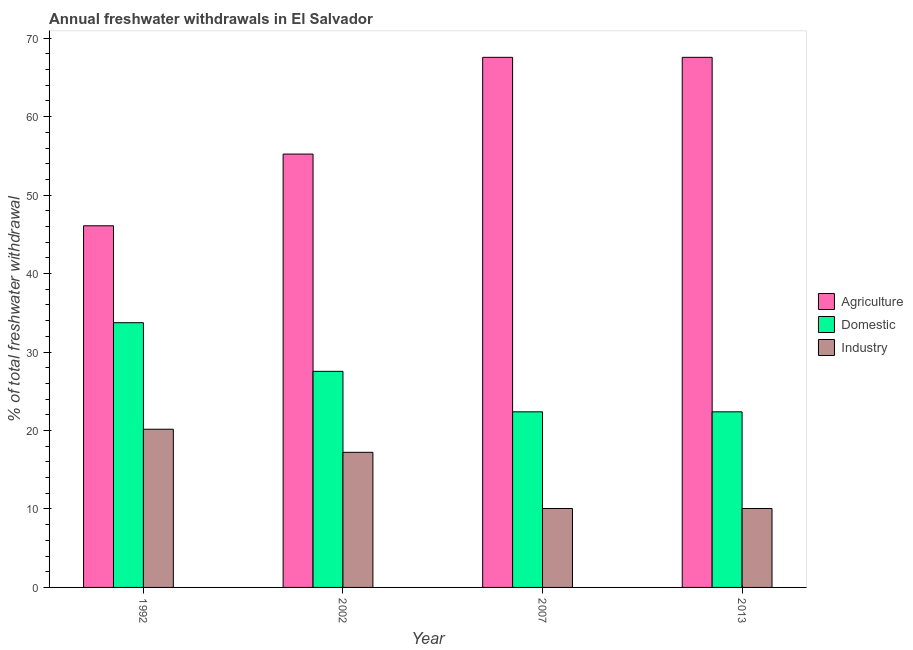How many different coloured bars are there?
Your answer should be very brief. 3. Are the number of bars per tick equal to the number of legend labels?
Your answer should be very brief. Yes. Are the number of bars on each tick of the X-axis equal?
Keep it short and to the point. Yes. How many bars are there on the 1st tick from the left?
Your response must be concise. 3. In how many cases, is the number of bars for a given year not equal to the number of legend labels?
Provide a succinct answer. 0. What is the percentage of freshwater withdrawal for agriculture in 2007?
Offer a terse response. 67.56. Across all years, what is the maximum percentage of freshwater withdrawal for industry?
Your answer should be very brief. 20.16. Across all years, what is the minimum percentage of freshwater withdrawal for agriculture?
Offer a very short reply. 46.09. What is the total percentage of freshwater withdrawal for industry in the graph?
Give a very brief answer. 57.5. What is the difference between the percentage of freshwater withdrawal for domestic purposes in 1992 and that in 2002?
Provide a short and direct response. 6.2. What is the difference between the percentage of freshwater withdrawal for agriculture in 2007 and the percentage of freshwater withdrawal for domestic purposes in 2002?
Keep it short and to the point. 12.33. What is the average percentage of freshwater withdrawal for agriculture per year?
Give a very brief answer. 59.11. In the year 2007, what is the difference between the percentage of freshwater withdrawal for domestic purposes and percentage of freshwater withdrawal for agriculture?
Your answer should be very brief. 0. In how many years, is the percentage of freshwater withdrawal for agriculture greater than 58 %?
Make the answer very short. 2. What is the ratio of the percentage of freshwater withdrawal for domestic purposes in 1992 to that in 2002?
Your answer should be very brief. 1.23. What is the difference between the highest and the second highest percentage of freshwater withdrawal for agriculture?
Your answer should be compact. 0. What is the difference between the highest and the lowest percentage of freshwater withdrawal for domestic purposes?
Your answer should be very brief. 11.36. Is the sum of the percentage of freshwater withdrawal for domestic purposes in 2007 and 2013 greater than the maximum percentage of freshwater withdrawal for industry across all years?
Make the answer very short. Yes. What does the 3rd bar from the left in 2007 represents?
Offer a very short reply. Industry. What does the 2nd bar from the right in 2002 represents?
Ensure brevity in your answer.  Domestic. Is it the case that in every year, the sum of the percentage of freshwater withdrawal for agriculture and percentage of freshwater withdrawal for domestic purposes is greater than the percentage of freshwater withdrawal for industry?
Provide a succinct answer. Yes. Are all the bars in the graph horizontal?
Provide a short and direct response. No. How many years are there in the graph?
Your answer should be very brief. 4. Are the values on the major ticks of Y-axis written in scientific E-notation?
Ensure brevity in your answer.  No. Where does the legend appear in the graph?
Your answer should be very brief. Center right. How are the legend labels stacked?
Your answer should be compact. Vertical. What is the title of the graph?
Provide a succinct answer. Annual freshwater withdrawals in El Salvador. Does "Social Protection" appear as one of the legend labels in the graph?
Ensure brevity in your answer.  No. What is the label or title of the Y-axis?
Your answer should be very brief. % of total freshwater withdrawal. What is the % of total freshwater withdrawal in Agriculture in 1992?
Give a very brief answer. 46.09. What is the % of total freshwater withdrawal of Domestic in 1992?
Provide a short and direct response. 33.74. What is the % of total freshwater withdrawal in Industry in 1992?
Ensure brevity in your answer.  20.16. What is the % of total freshwater withdrawal of Agriculture in 2002?
Your answer should be compact. 55.23. What is the % of total freshwater withdrawal of Domestic in 2002?
Keep it short and to the point. 27.54. What is the % of total freshwater withdrawal of Industry in 2002?
Keep it short and to the point. 17.22. What is the % of total freshwater withdrawal of Agriculture in 2007?
Offer a very short reply. 67.56. What is the % of total freshwater withdrawal of Domestic in 2007?
Offer a terse response. 22.38. What is the % of total freshwater withdrawal in Industry in 2007?
Provide a short and direct response. 10.06. What is the % of total freshwater withdrawal of Agriculture in 2013?
Ensure brevity in your answer.  67.56. What is the % of total freshwater withdrawal of Domestic in 2013?
Your response must be concise. 22.38. What is the % of total freshwater withdrawal in Industry in 2013?
Your answer should be very brief. 10.06. Across all years, what is the maximum % of total freshwater withdrawal in Agriculture?
Provide a succinct answer. 67.56. Across all years, what is the maximum % of total freshwater withdrawal of Domestic?
Give a very brief answer. 33.74. Across all years, what is the maximum % of total freshwater withdrawal in Industry?
Your response must be concise. 20.16. Across all years, what is the minimum % of total freshwater withdrawal in Agriculture?
Make the answer very short. 46.09. Across all years, what is the minimum % of total freshwater withdrawal of Domestic?
Keep it short and to the point. 22.38. Across all years, what is the minimum % of total freshwater withdrawal in Industry?
Provide a succinct answer. 10.06. What is the total % of total freshwater withdrawal of Agriculture in the graph?
Give a very brief answer. 236.44. What is the total % of total freshwater withdrawal of Domestic in the graph?
Your response must be concise. 106.04. What is the total % of total freshwater withdrawal of Industry in the graph?
Offer a very short reply. 57.5. What is the difference between the % of total freshwater withdrawal in Agriculture in 1992 and that in 2002?
Provide a short and direct response. -9.14. What is the difference between the % of total freshwater withdrawal in Domestic in 1992 and that in 2002?
Your response must be concise. 6.2. What is the difference between the % of total freshwater withdrawal of Industry in 1992 and that in 2002?
Your response must be concise. 2.94. What is the difference between the % of total freshwater withdrawal of Agriculture in 1992 and that in 2007?
Your answer should be very brief. -21.47. What is the difference between the % of total freshwater withdrawal in Domestic in 1992 and that in 2007?
Ensure brevity in your answer.  11.36. What is the difference between the % of total freshwater withdrawal of Agriculture in 1992 and that in 2013?
Your answer should be compact. -21.47. What is the difference between the % of total freshwater withdrawal of Domestic in 1992 and that in 2013?
Your answer should be compact. 11.36. What is the difference between the % of total freshwater withdrawal in Industry in 1992 and that in 2013?
Give a very brief answer. 10.1. What is the difference between the % of total freshwater withdrawal of Agriculture in 2002 and that in 2007?
Your response must be concise. -12.33. What is the difference between the % of total freshwater withdrawal of Domestic in 2002 and that in 2007?
Provide a short and direct response. 5.16. What is the difference between the % of total freshwater withdrawal of Industry in 2002 and that in 2007?
Offer a very short reply. 7.16. What is the difference between the % of total freshwater withdrawal of Agriculture in 2002 and that in 2013?
Your answer should be very brief. -12.33. What is the difference between the % of total freshwater withdrawal in Domestic in 2002 and that in 2013?
Your answer should be very brief. 5.16. What is the difference between the % of total freshwater withdrawal in Industry in 2002 and that in 2013?
Provide a short and direct response. 7.16. What is the difference between the % of total freshwater withdrawal of Agriculture in 2007 and that in 2013?
Provide a succinct answer. 0. What is the difference between the % of total freshwater withdrawal in Domestic in 2007 and that in 2013?
Give a very brief answer. 0. What is the difference between the % of total freshwater withdrawal of Agriculture in 1992 and the % of total freshwater withdrawal of Domestic in 2002?
Give a very brief answer. 18.55. What is the difference between the % of total freshwater withdrawal of Agriculture in 1992 and the % of total freshwater withdrawal of Industry in 2002?
Your answer should be very brief. 28.87. What is the difference between the % of total freshwater withdrawal in Domestic in 1992 and the % of total freshwater withdrawal in Industry in 2002?
Keep it short and to the point. 16.52. What is the difference between the % of total freshwater withdrawal in Agriculture in 1992 and the % of total freshwater withdrawal in Domestic in 2007?
Your response must be concise. 23.71. What is the difference between the % of total freshwater withdrawal in Agriculture in 1992 and the % of total freshwater withdrawal in Industry in 2007?
Provide a succinct answer. 36.03. What is the difference between the % of total freshwater withdrawal in Domestic in 1992 and the % of total freshwater withdrawal in Industry in 2007?
Your answer should be very brief. 23.68. What is the difference between the % of total freshwater withdrawal of Agriculture in 1992 and the % of total freshwater withdrawal of Domestic in 2013?
Your answer should be very brief. 23.71. What is the difference between the % of total freshwater withdrawal of Agriculture in 1992 and the % of total freshwater withdrawal of Industry in 2013?
Keep it short and to the point. 36.03. What is the difference between the % of total freshwater withdrawal of Domestic in 1992 and the % of total freshwater withdrawal of Industry in 2013?
Your answer should be compact. 23.68. What is the difference between the % of total freshwater withdrawal of Agriculture in 2002 and the % of total freshwater withdrawal of Domestic in 2007?
Make the answer very short. 32.85. What is the difference between the % of total freshwater withdrawal in Agriculture in 2002 and the % of total freshwater withdrawal in Industry in 2007?
Keep it short and to the point. 45.17. What is the difference between the % of total freshwater withdrawal in Domestic in 2002 and the % of total freshwater withdrawal in Industry in 2007?
Your answer should be very brief. 17.48. What is the difference between the % of total freshwater withdrawal in Agriculture in 2002 and the % of total freshwater withdrawal in Domestic in 2013?
Ensure brevity in your answer.  32.85. What is the difference between the % of total freshwater withdrawal in Agriculture in 2002 and the % of total freshwater withdrawal in Industry in 2013?
Provide a succinct answer. 45.17. What is the difference between the % of total freshwater withdrawal of Domestic in 2002 and the % of total freshwater withdrawal of Industry in 2013?
Keep it short and to the point. 17.48. What is the difference between the % of total freshwater withdrawal of Agriculture in 2007 and the % of total freshwater withdrawal of Domestic in 2013?
Your answer should be very brief. 45.18. What is the difference between the % of total freshwater withdrawal of Agriculture in 2007 and the % of total freshwater withdrawal of Industry in 2013?
Give a very brief answer. 57.5. What is the difference between the % of total freshwater withdrawal of Domestic in 2007 and the % of total freshwater withdrawal of Industry in 2013?
Provide a succinct answer. 12.32. What is the average % of total freshwater withdrawal of Agriculture per year?
Your answer should be compact. 59.11. What is the average % of total freshwater withdrawal of Domestic per year?
Make the answer very short. 26.51. What is the average % of total freshwater withdrawal in Industry per year?
Offer a very short reply. 14.38. In the year 1992, what is the difference between the % of total freshwater withdrawal of Agriculture and % of total freshwater withdrawal of Domestic?
Provide a succinct answer. 12.35. In the year 1992, what is the difference between the % of total freshwater withdrawal of Agriculture and % of total freshwater withdrawal of Industry?
Ensure brevity in your answer.  25.93. In the year 1992, what is the difference between the % of total freshwater withdrawal of Domestic and % of total freshwater withdrawal of Industry?
Your answer should be very brief. 13.58. In the year 2002, what is the difference between the % of total freshwater withdrawal of Agriculture and % of total freshwater withdrawal of Domestic?
Provide a succinct answer. 27.69. In the year 2002, what is the difference between the % of total freshwater withdrawal in Agriculture and % of total freshwater withdrawal in Industry?
Provide a succinct answer. 38.01. In the year 2002, what is the difference between the % of total freshwater withdrawal of Domestic and % of total freshwater withdrawal of Industry?
Provide a short and direct response. 10.32. In the year 2007, what is the difference between the % of total freshwater withdrawal of Agriculture and % of total freshwater withdrawal of Domestic?
Provide a short and direct response. 45.18. In the year 2007, what is the difference between the % of total freshwater withdrawal in Agriculture and % of total freshwater withdrawal in Industry?
Ensure brevity in your answer.  57.5. In the year 2007, what is the difference between the % of total freshwater withdrawal of Domestic and % of total freshwater withdrawal of Industry?
Offer a very short reply. 12.32. In the year 2013, what is the difference between the % of total freshwater withdrawal in Agriculture and % of total freshwater withdrawal in Domestic?
Provide a succinct answer. 45.18. In the year 2013, what is the difference between the % of total freshwater withdrawal in Agriculture and % of total freshwater withdrawal in Industry?
Your answer should be compact. 57.5. In the year 2013, what is the difference between the % of total freshwater withdrawal of Domestic and % of total freshwater withdrawal of Industry?
Your answer should be very brief. 12.32. What is the ratio of the % of total freshwater withdrawal of Agriculture in 1992 to that in 2002?
Give a very brief answer. 0.83. What is the ratio of the % of total freshwater withdrawal in Domestic in 1992 to that in 2002?
Keep it short and to the point. 1.23. What is the ratio of the % of total freshwater withdrawal of Industry in 1992 to that in 2002?
Offer a very short reply. 1.17. What is the ratio of the % of total freshwater withdrawal in Agriculture in 1992 to that in 2007?
Ensure brevity in your answer.  0.68. What is the ratio of the % of total freshwater withdrawal in Domestic in 1992 to that in 2007?
Give a very brief answer. 1.51. What is the ratio of the % of total freshwater withdrawal in Industry in 1992 to that in 2007?
Your answer should be very brief. 2. What is the ratio of the % of total freshwater withdrawal of Agriculture in 1992 to that in 2013?
Offer a very short reply. 0.68. What is the ratio of the % of total freshwater withdrawal of Domestic in 1992 to that in 2013?
Ensure brevity in your answer.  1.51. What is the ratio of the % of total freshwater withdrawal of Industry in 1992 to that in 2013?
Keep it short and to the point. 2. What is the ratio of the % of total freshwater withdrawal in Agriculture in 2002 to that in 2007?
Offer a terse response. 0.82. What is the ratio of the % of total freshwater withdrawal of Domestic in 2002 to that in 2007?
Your answer should be very brief. 1.23. What is the ratio of the % of total freshwater withdrawal in Industry in 2002 to that in 2007?
Provide a short and direct response. 1.71. What is the ratio of the % of total freshwater withdrawal in Agriculture in 2002 to that in 2013?
Offer a terse response. 0.82. What is the ratio of the % of total freshwater withdrawal in Domestic in 2002 to that in 2013?
Keep it short and to the point. 1.23. What is the ratio of the % of total freshwater withdrawal of Industry in 2002 to that in 2013?
Give a very brief answer. 1.71. What is the ratio of the % of total freshwater withdrawal of Agriculture in 2007 to that in 2013?
Your response must be concise. 1. What is the ratio of the % of total freshwater withdrawal of Domestic in 2007 to that in 2013?
Provide a succinct answer. 1. What is the ratio of the % of total freshwater withdrawal of Industry in 2007 to that in 2013?
Your answer should be compact. 1. What is the difference between the highest and the second highest % of total freshwater withdrawal in Agriculture?
Ensure brevity in your answer.  0. What is the difference between the highest and the second highest % of total freshwater withdrawal of Domestic?
Provide a succinct answer. 6.2. What is the difference between the highest and the second highest % of total freshwater withdrawal of Industry?
Give a very brief answer. 2.94. What is the difference between the highest and the lowest % of total freshwater withdrawal of Agriculture?
Give a very brief answer. 21.47. What is the difference between the highest and the lowest % of total freshwater withdrawal of Domestic?
Make the answer very short. 11.36. What is the difference between the highest and the lowest % of total freshwater withdrawal in Industry?
Your answer should be compact. 10.1. 